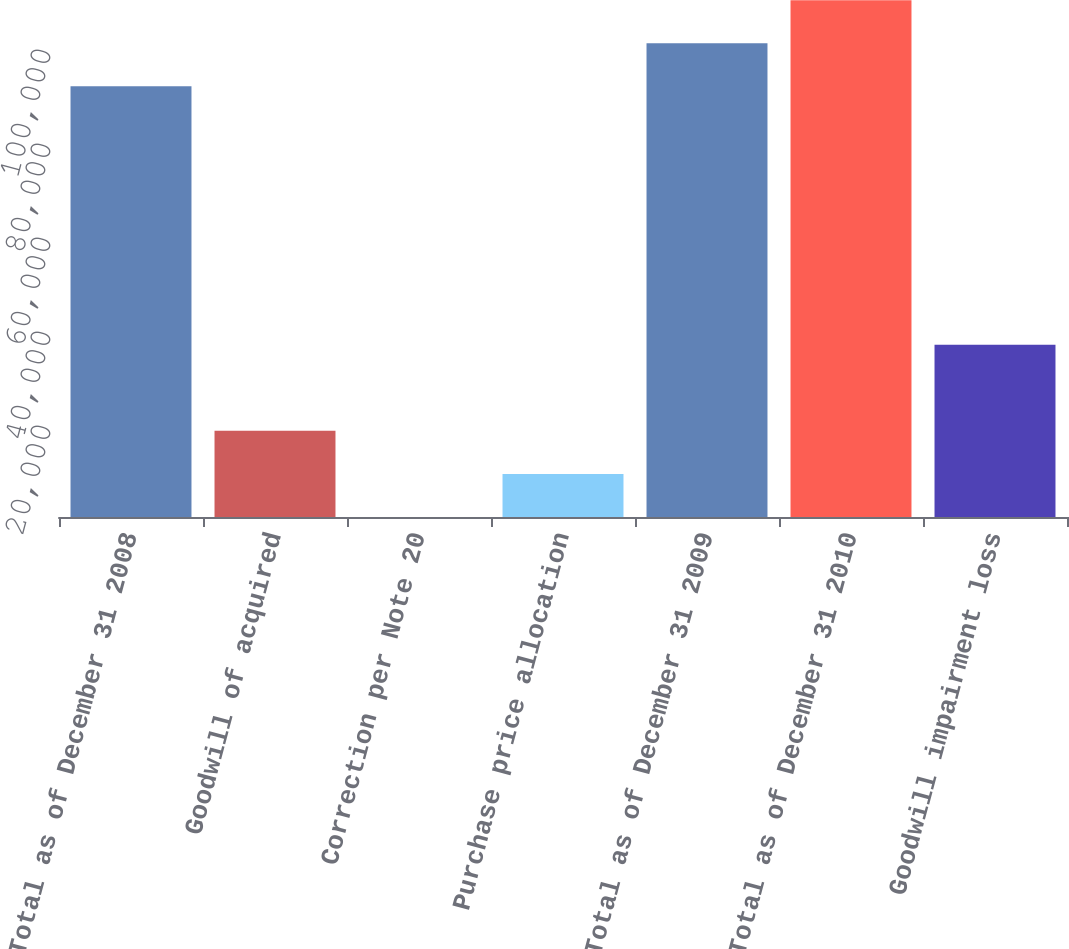Convert chart. <chart><loc_0><loc_0><loc_500><loc_500><bar_chart><fcel>Total as of December 31 2008<fcel>Goodwill of acquired<fcel>Correction per Note 20<fcel>Purchase price allocation<fcel>Total as of December 31 2009<fcel>Total as of December 31 2010<fcel>Goodwill impairment loss<nl><fcel>91633<fcel>18327.4<fcel>0.99<fcel>9164.19<fcel>100796<fcel>109959<fcel>36653.8<nl></chart> 